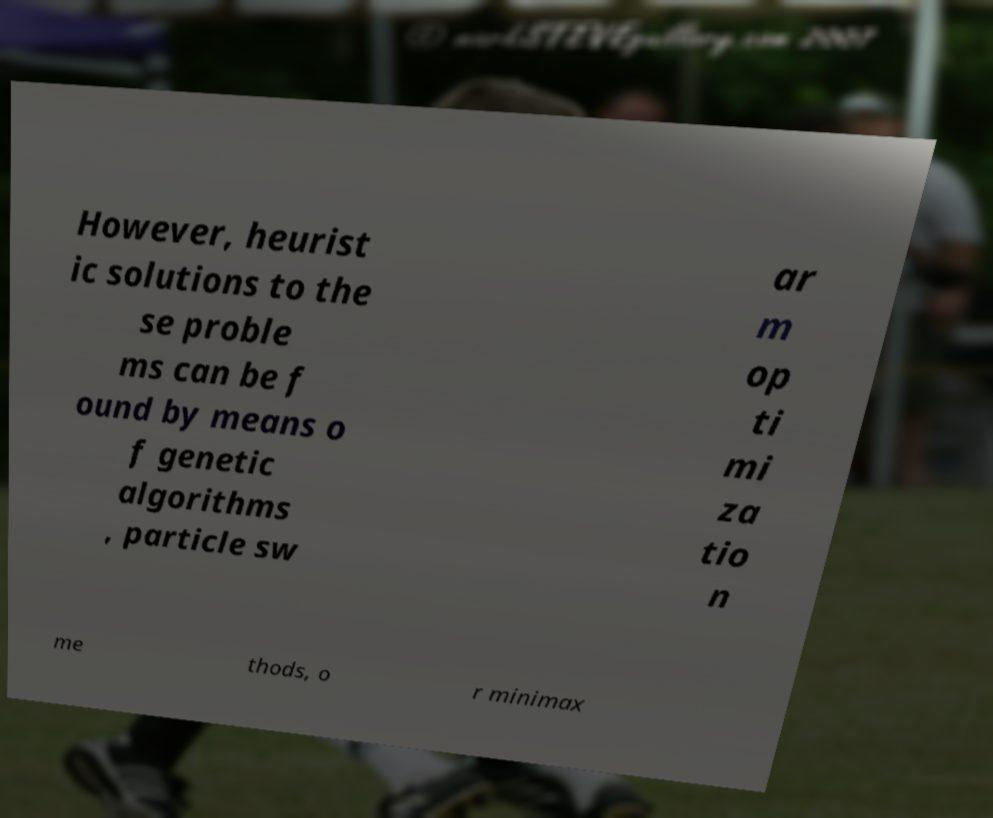Could you extract and type out the text from this image? However, heurist ic solutions to the se proble ms can be f ound by means o f genetic algorithms , particle sw ar m op ti mi za tio n me thods, o r minimax 